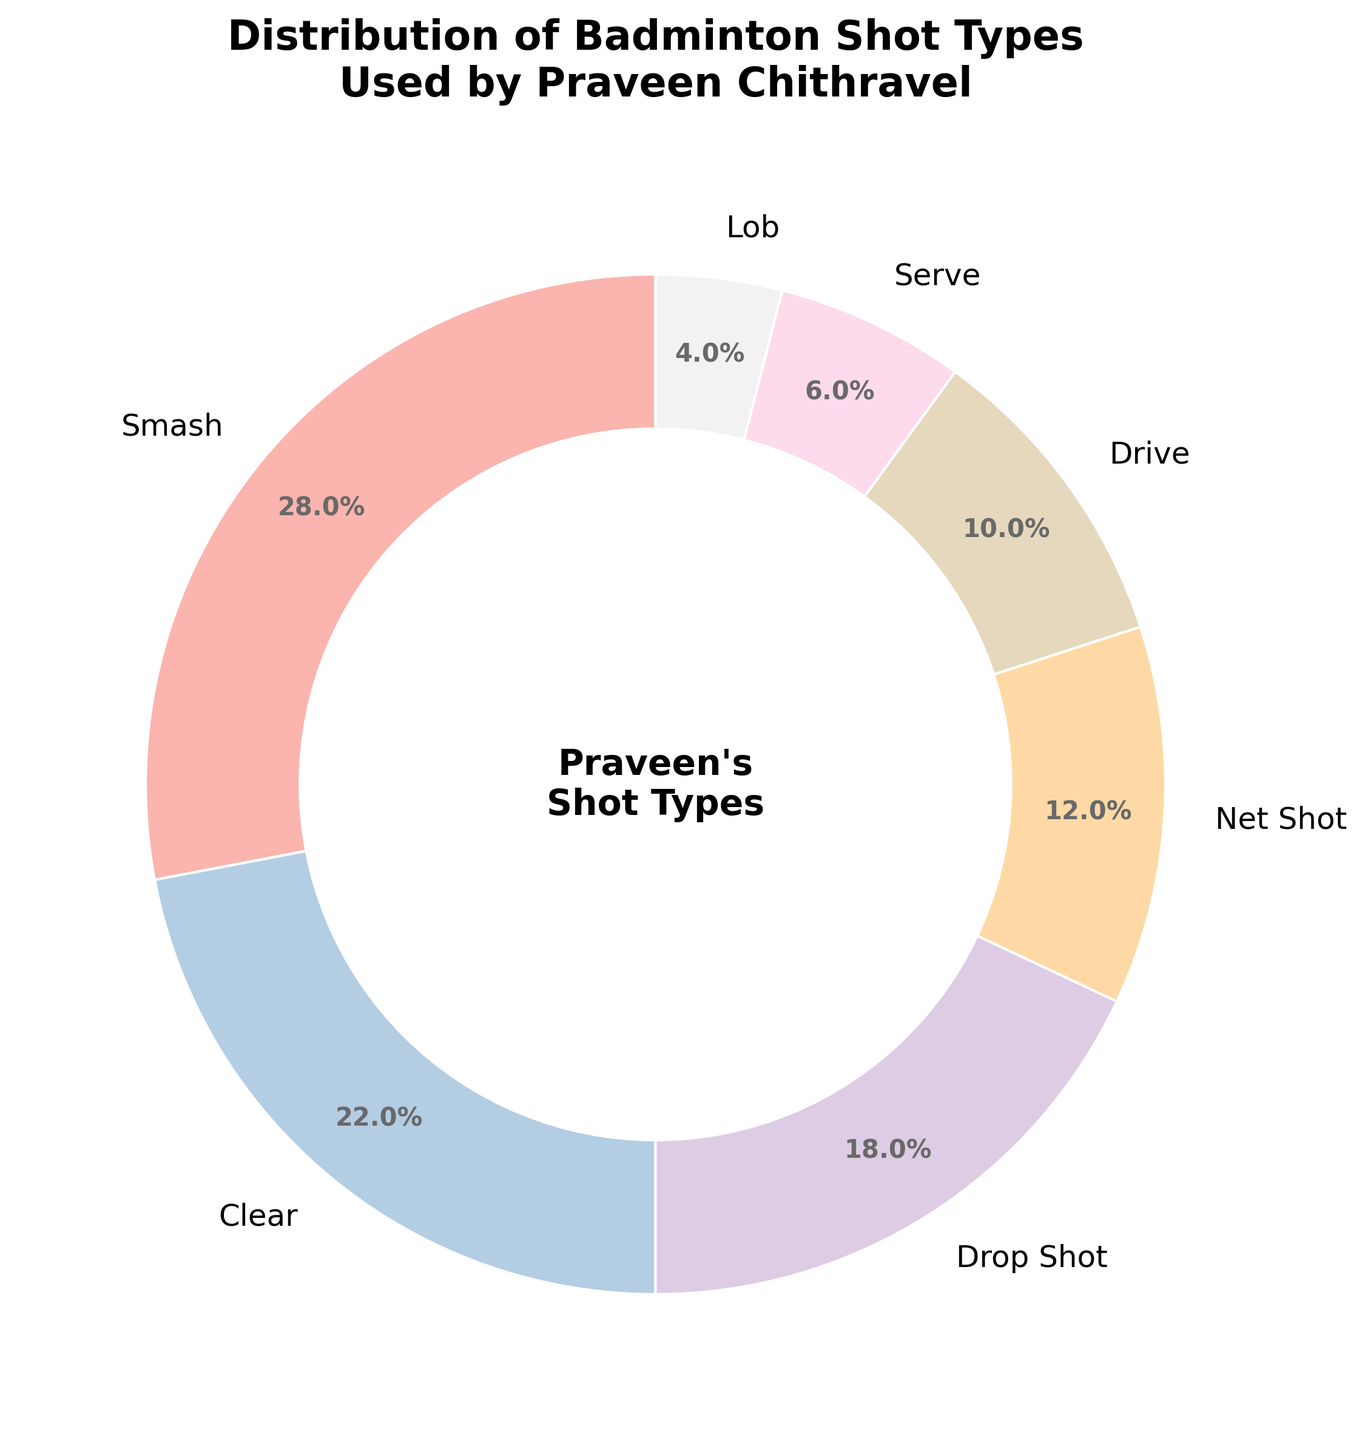Which shot type does Praveen use the most? The largest segment in the pie chart represents the Smash shot type with 28%.
Answer: Smash What is the total percentage of Clear and Drop Shot combined? Adding the percentages of Clear (22%) and Drop Shot (18%) gives 22 + 18 = 40.
Answer: 40% Compare the usage of Serve and Lob shot types. Which one does Praveen use more? The pie chart shows Serve at 6% and Lob at 4%, so Serve is used more frequently.
Answer: Serve How much more frequently does Praveen use Net Shot compared to Drive? The percentage for Net Shot is 12% and for Drive is 10%. The difference is 12 - 10 = 2%.
Answer: 2% If you sum the percentages of Smash, Clear, and Drop Shot, what fraction of Praveen's shots do they make up? Adding the percentages of Smash (28%), Clear (22%), and Drop Shot (18%) gives 28 + 22 + 18 = 68. This represents 68% of his shots.
Answer: 68% Which shot type is the least used by Praveen? The smallest segment in the pie chart is the Lob shot type with 4%.
Answer: Lob Is the percentage of Drive shots greater than, less than, or equal to the percentage of Serve shots and by how much? Drive is 10% and Serve is 6%, so Drive is greater. The difference is 10 - 6 = 4%.
Answer: Greater by 4% How many shot types have a percentage of 10% or less? The pie chart shows Drive (10%), Serve (6%), and Lob (4%) making it three shot types with 10% or less.
Answer: 3 Which shot types combined make up more than half of Praveen's shots? The percentages for Smash (28%), Clear (22%), and Drop Shot (18%) combined are 68%, which is more than half.
Answer: Smash, Clear, Drop Shot 